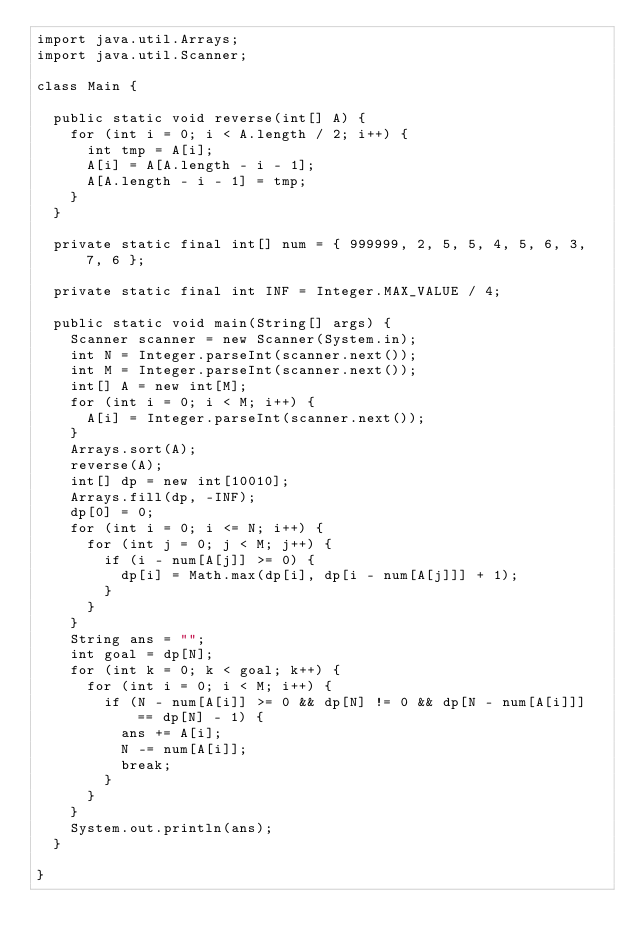<code> <loc_0><loc_0><loc_500><loc_500><_Java_>import java.util.Arrays;
import java.util.Scanner;

class Main {

  public static void reverse(int[] A) {
    for (int i = 0; i < A.length / 2; i++) {
      int tmp = A[i];
      A[i] = A[A.length - i - 1];
      A[A.length - i - 1] = tmp;
    }
  }

  private static final int[] num = { 999999, 2, 5, 5, 4, 5, 6, 3, 7, 6 };

  private static final int INF = Integer.MAX_VALUE / 4;

  public static void main(String[] args) {
    Scanner scanner = new Scanner(System.in);
    int N = Integer.parseInt(scanner.next());
    int M = Integer.parseInt(scanner.next());
    int[] A = new int[M];
    for (int i = 0; i < M; i++) {
      A[i] = Integer.parseInt(scanner.next());
    }
    Arrays.sort(A);
    reverse(A);
    int[] dp = new int[10010];
    Arrays.fill(dp, -INF);
    dp[0] = 0;
    for (int i = 0; i <= N; i++) {
      for (int j = 0; j < M; j++) {
        if (i - num[A[j]] >= 0) {
          dp[i] = Math.max(dp[i], dp[i - num[A[j]]] + 1);
        }
      }
    }
    String ans = "";
    int goal = dp[N];
    for (int k = 0; k < goal; k++) {
      for (int i = 0; i < M; i++) {
        if (N - num[A[i]] >= 0 && dp[N] != 0 && dp[N - num[A[i]]] == dp[N] - 1) {
          ans += A[i];
          N -= num[A[i]];
          break;
        }
      }
    }
    System.out.println(ans);
  }

}
</code> 